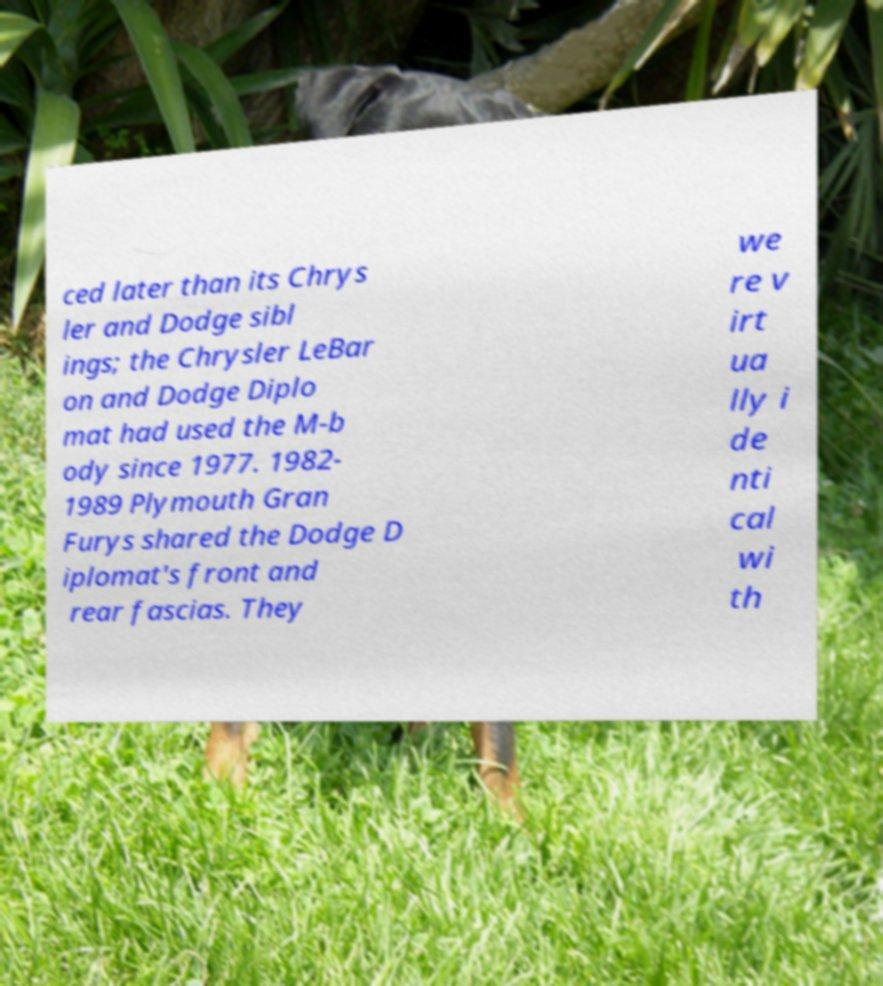Could you assist in decoding the text presented in this image and type it out clearly? ced later than its Chrys ler and Dodge sibl ings; the Chrysler LeBar on and Dodge Diplo mat had used the M-b ody since 1977. 1982- 1989 Plymouth Gran Furys shared the Dodge D iplomat's front and rear fascias. They we re v irt ua lly i de nti cal wi th 